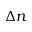Convert formula to latex. <formula><loc_0><loc_0><loc_500><loc_500>\Delta n</formula> 